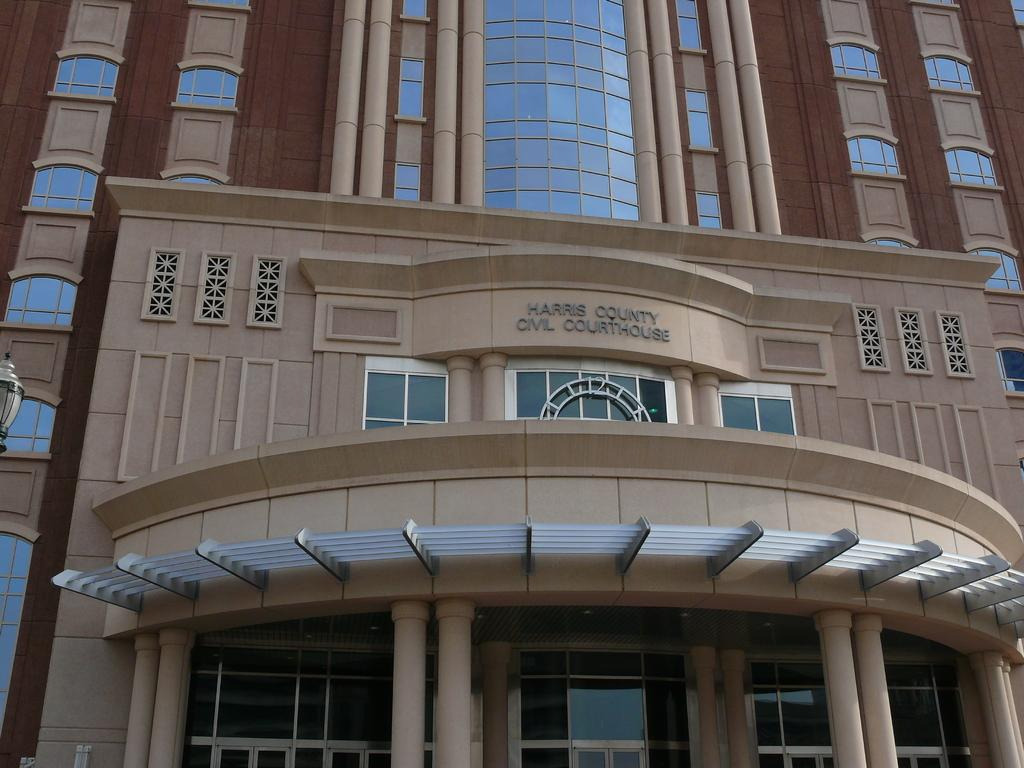What type of structure is present in the image? There is a building in the image. What architectural features can be seen on the building? The building has windows and pillars. Is there any text visible on the building? Yes, there is text visible on the wall of the building. How many cherries are hanging from the building in the image? There are no cherries present in the image; it features a building with windows, pillars, and text on the wall. Can you describe the flight path of the airplane in the image? There is no airplane present in the image; it only features a building with windows, pillars, and text on the wall. 